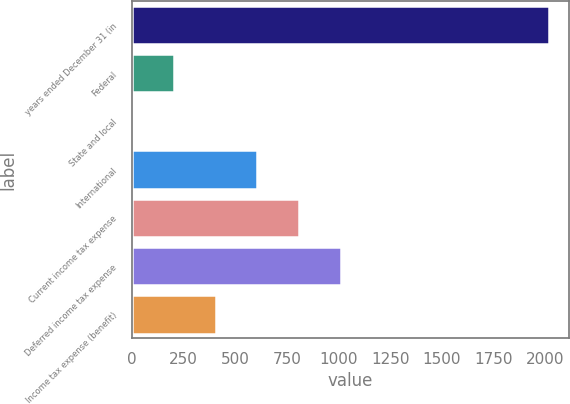<chart> <loc_0><loc_0><loc_500><loc_500><bar_chart><fcel>years ended December 31 (in<fcel>Federal<fcel>State and local<fcel>International<fcel>Current income tax expense<fcel>Deferred income tax expense<fcel>Income tax expense (benefit)<nl><fcel>2016<fcel>204.3<fcel>3<fcel>606.9<fcel>808.2<fcel>1009.5<fcel>405.6<nl></chart> 